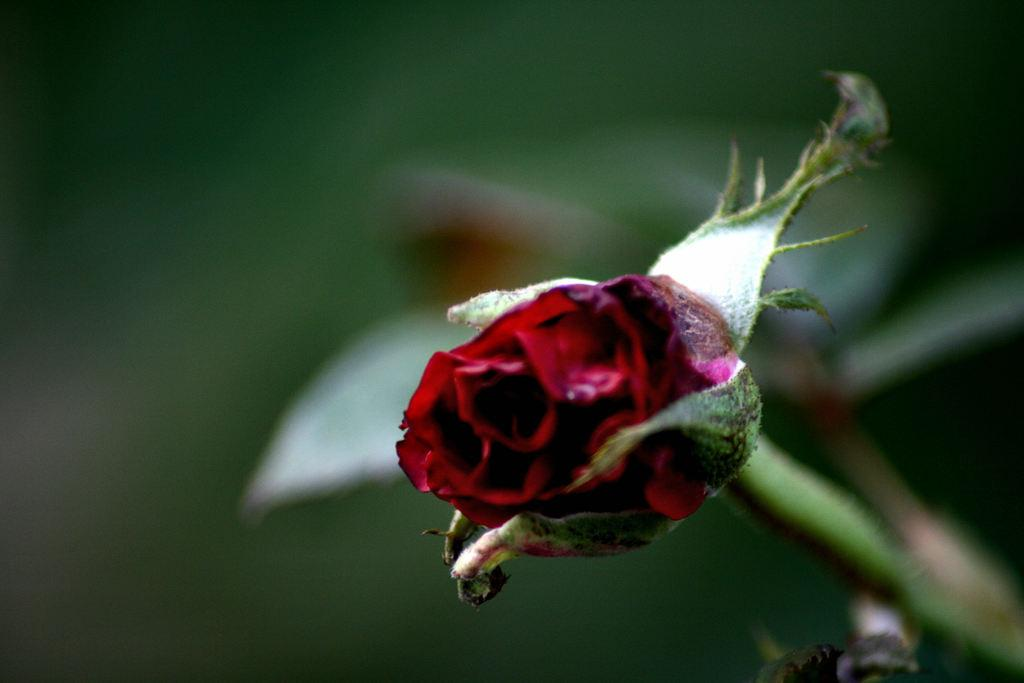What is the main subject of the image? The main subject of the image is a stem with a flower. Can you describe the flower in the image? The flower is red in color. Are there any other flowers visible in the image? Yes, there are other flowers visible behind the red flower, but they are not clearly visible. What type of waste can be seen in the image? There is no waste present in the image; it features a stem with a red flower and other flowers in the background. How many boys are visible in the image? There are no boys present in the image. 